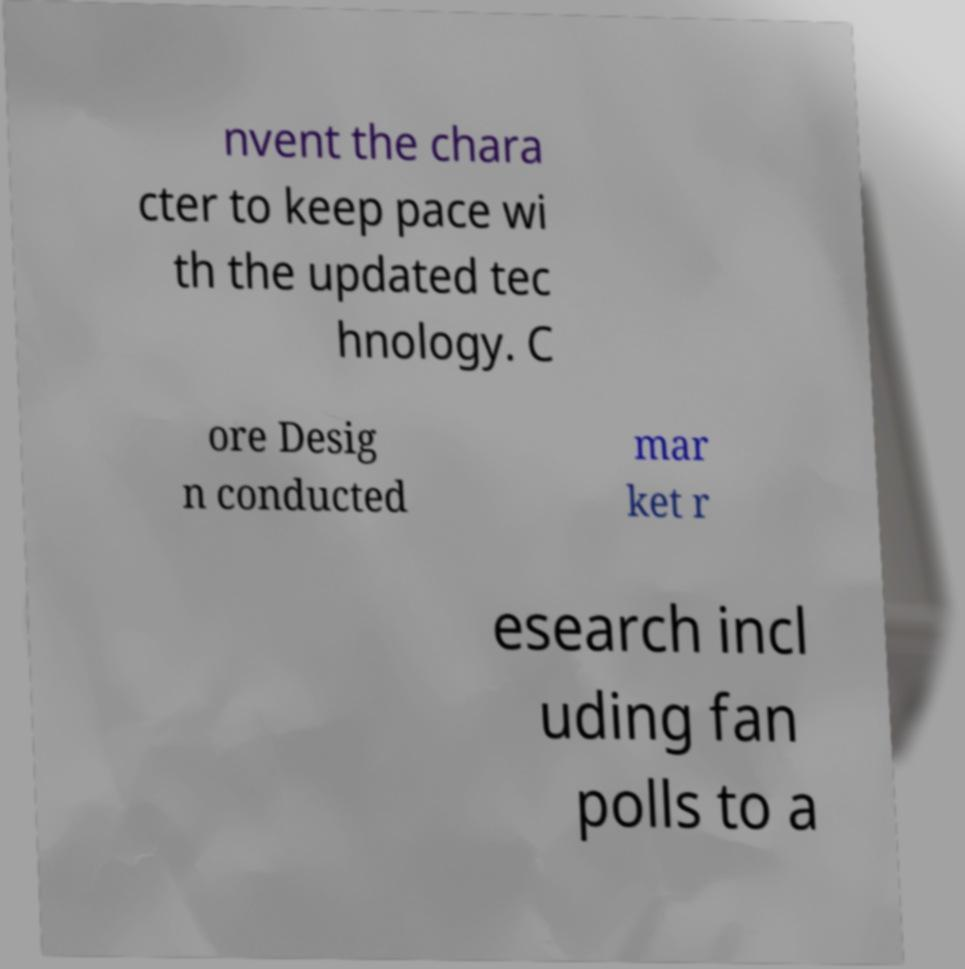Could you extract and type out the text from this image? nvent the chara cter to keep pace wi th the updated tec hnology. C ore Desig n conducted mar ket r esearch incl uding fan polls to a 